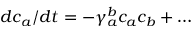Convert formula to latex. <formula><loc_0><loc_0><loc_500><loc_500>d c _ { a } / d t = - \gamma _ { a } ^ { b } c _ { a } c _ { b } + \dots</formula> 